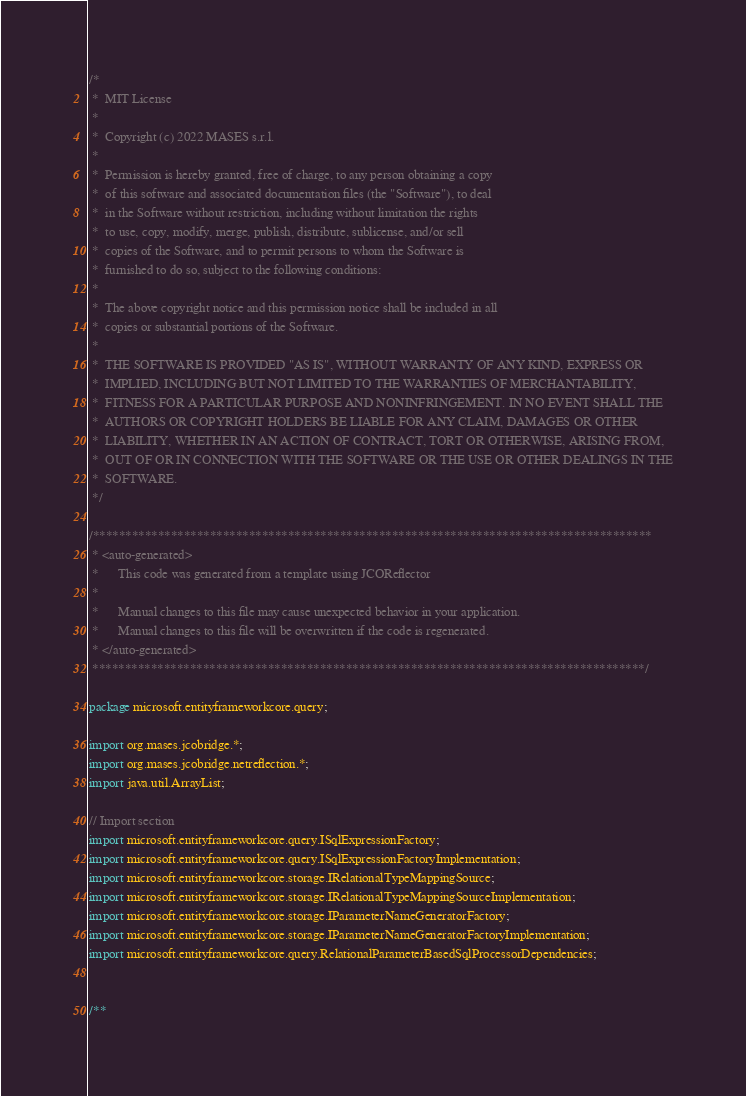<code> <loc_0><loc_0><loc_500><loc_500><_Java_>/*
 *  MIT License
 *
 *  Copyright (c) 2022 MASES s.r.l.
 *
 *  Permission is hereby granted, free of charge, to any person obtaining a copy
 *  of this software and associated documentation files (the "Software"), to deal
 *  in the Software without restriction, including without limitation the rights
 *  to use, copy, modify, merge, publish, distribute, sublicense, and/or sell
 *  copies of the Software, and to permit persons to whom the Software is
 *  furnished to do so, subject to the following conditions:
 *
 *  The above copyright notice and this permission notice shall be included in all
 *  copies or substantial portions of the Software.
 *
 *  THE SOFTWARE IS PROVIDED "AS IS", WITHOUT WARRANTY OF ANY KIND, EXPRESS OR
 *  IMPLIED, INCLUDING BUT NOT LIMITED TO THE WARRANTIES OF MERCHANTABILITY,
 *  FITNESS FOR A PARTICULAR PURPOSE AND NONINFRINGEMENT. IN NO EVENT SHALL THE
 *  AUTHORS OR COPYRIGHT HOLDERS BE LIABLE FOR ANY CLAIM, DAMAGES OR OTHER
 *  LIABILITY, WHETHER IN AN ACTION OF CONTRACT, TORT OR OTHERWISE, ARISING FROM,
 *  OUT OF OR IN CONNECTION WITH THE SOFTWARE OR THE USE OR OTHER DEALINGS IN THE
 *  SOFTWARE.
 */

/**************************************************************************************
 * <auto-generated>
 *      This code was generated from a template using JCOReflector
 * 
 *      Manual changes to this file may cause unexpected behavior in your application.
 *      Manual changes to this file will be overwritten if the code is regenerated.
 * </auto-generated>
 *************************************************************************************/

package microsoft.entityframeworkcore.query;

import org.mases.jcobridge.*;
import org.mases.jcobridge.netreflection.*;
import java.util.ArrayList;

// Import section
import microsoft.entityframeworkcore.query.ISqlExpressionFactory;
import microsoft.entityframeworkcore.query.ISqlExpressionFactoryImplementation;
import microsoft.entityframeworkcore.storage.IRelationalTypeMappingSource;
import microsoft.entityframeworkcore.storage.IRelationalTypeMappingSourceImplementation;
import microsoft.entityframeworkcore.storage.IParameterNameGeneratorFactory;
import microsoft.entityframeworkcore.storage.IParameterNameGeneratorFactoryImplementation;
import microsoft.entityframeworkcore.query.RelationalParameterBasedSqlProcessorDependencies;


/**</code> 